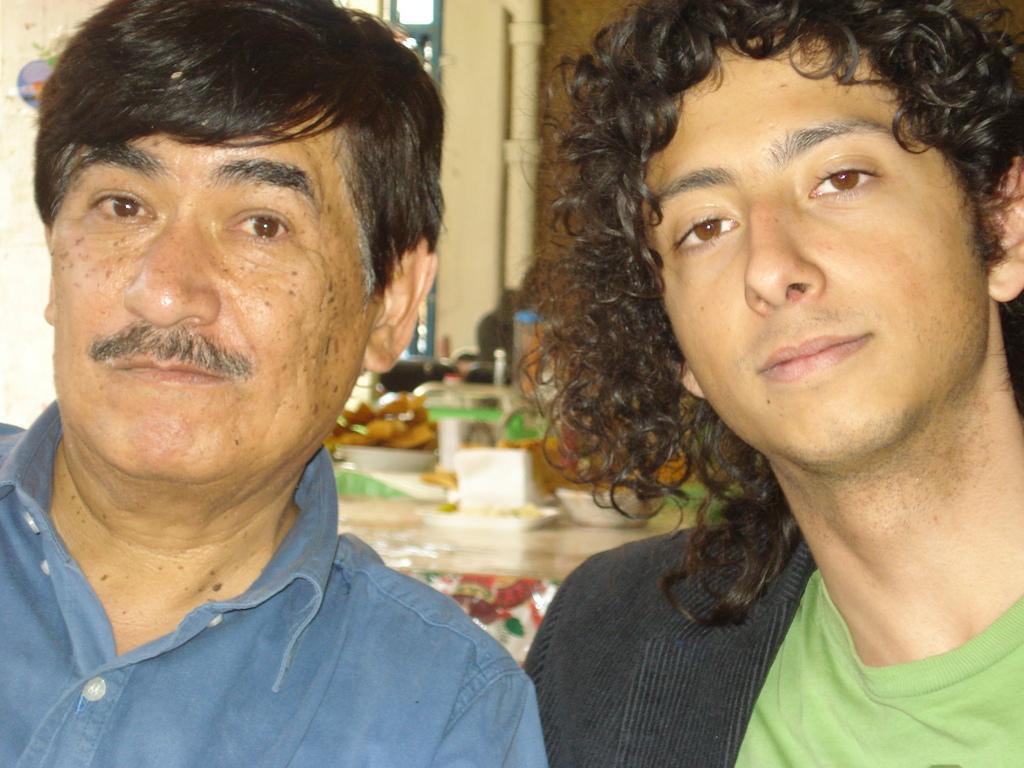Please provide a concise description of this image. In this picture we can see two persons in the front, in the background there is a table, we can see some plates on the table, we can see some food in these plates, there is a pipe here. 